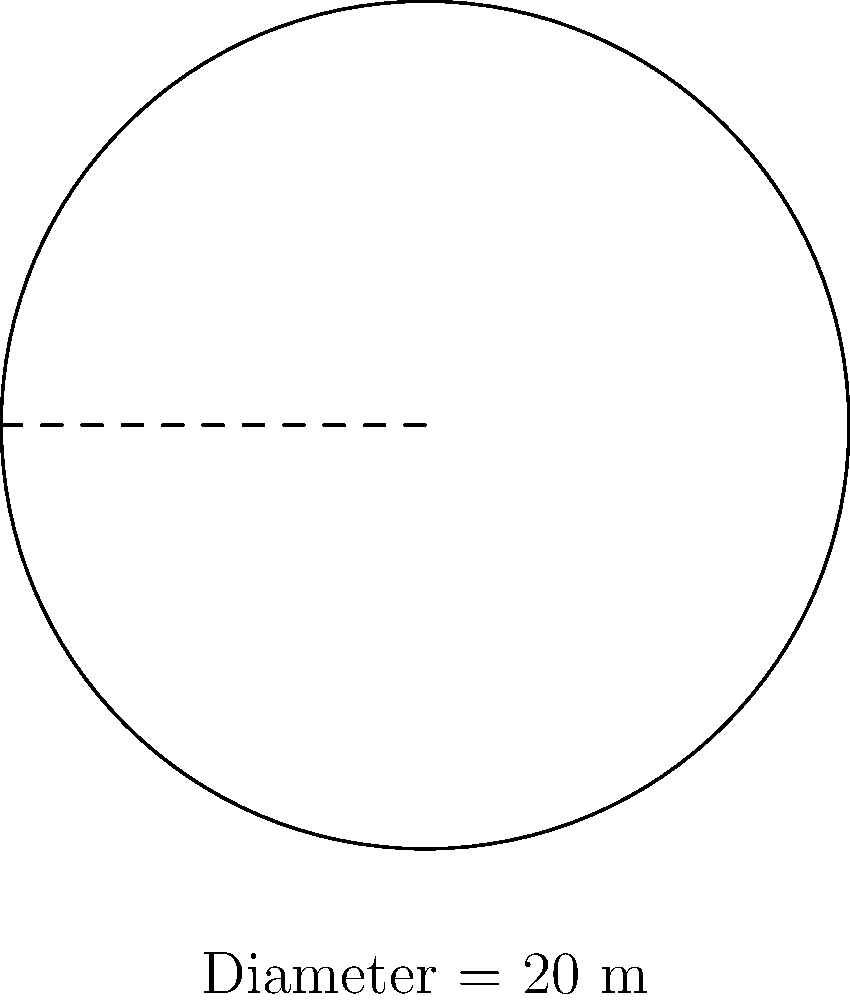A circular grain silo has a diameter of 20 meters. What is the floor area of the silo in square meters? Round your answer to the nearest whole number. To find the area of the circular silo floor, we need to use the formula for the area of a circle:

$$A = \pi r^2$$

Where:
$A$ = area
$\pi$ = pi (approximately 3.14159)
$r$ = radius

Steps:
1. Find the radius:
   The diameter is 20 meters, so the radius is half of that.
   $$r = 20 \div 2 = 10 \text{ meters}$$

2. Apply the formula:
   $$A = \pi r^2$$
   $$A = \pi \times 10^2$$
   $$A = \pi \times 100$$

3. Calculate:
   $$A \approx 3.14159 \times 100 \approx 314.159 \text{ square meters}$$

4. Round to the nearest whole number:
   $$314.159 \approx 314 \text{ square meters}$$
Answer: 314 square meters 